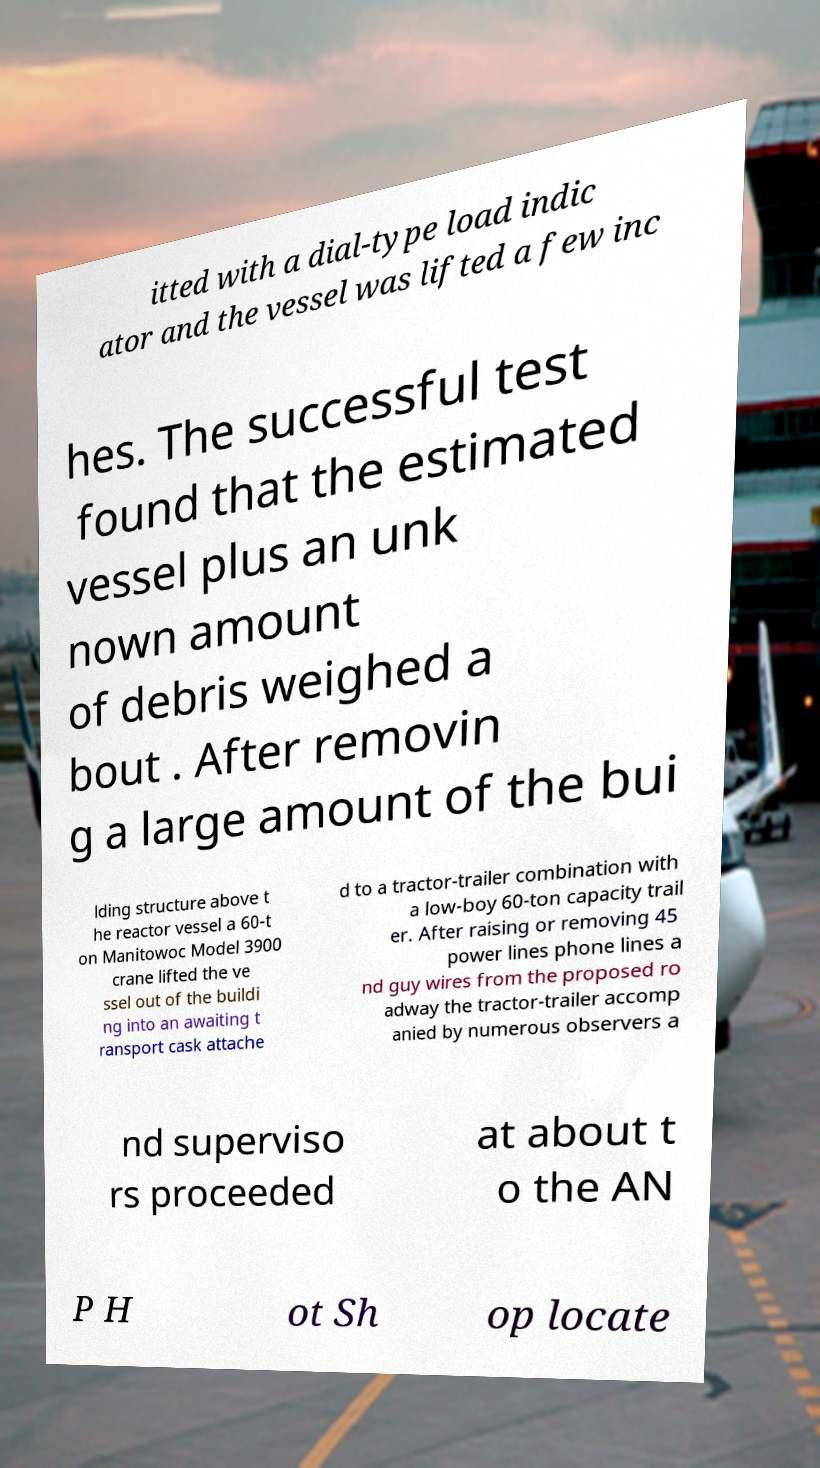Could you extract and type out the text from this image? itted with a dial-type load indic ator and the vessel was lifted a few inc hes. The successful test found that the estimated vessel plus an unk nown amount of debris weighed a bout . After removin g a large amount of the bui lding structure above t he reactor vessel a 60-t on Manitowoc Model 3900 crane lifted the ve ssel out of the buildi ng into an awaiting t ransport cask attache d to a tractor-trailer combination with a low-boy 60-ton capacity trail er. After raising or removing 45 power lines phone lines a nd guy wires from the proposed ro adway the tractor-trailer accomp anied by numerous observers a nd superviso rs proceeded at about t o the AN P H ot Sh op locate 